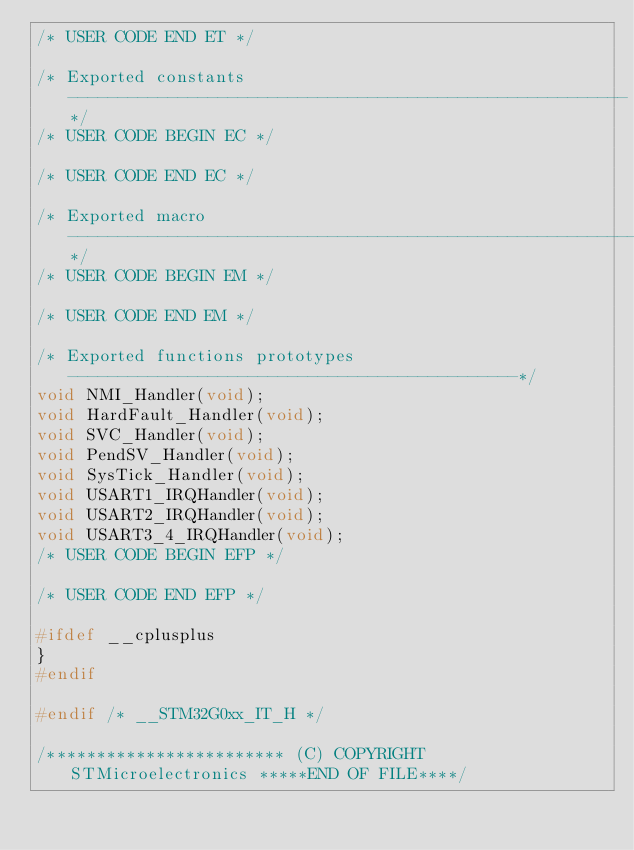Convert code to text. <code><loc_0><loc_0><loc_500><loc_500><_C_>/* USER CODE END ET */

/* Exported constants --------------------------------------------------------*/
/* USER CODE BEGIN EC */

/* USER CODE END EC */

/* Exported macro ------------------------------------------------------------*/
/* USER CODE BEGIN EM */

/* USER CODE END EM */

/* Exported functions prototypes ---------------------------------------------*/
void NMI_Handler(void);
void HardFault_Handler(void);
void SVC_Handler(void);
void PendSV_Handler(void);
void SysTick_Handler(void);
void USART1_IRQHandler(void);
void USART2_IRQHandler(void);
void USART3_4_IRQHandler(void);
/* USER CODE BEGIN EFP */

/* USER CODE END EFP */

#ifdef __cplusplus
}
#endif

#endif /* __STM32G0xx_IT_H */

/************************ (C) COPYRIGHT STMicroelectronics *****END OF FILE****/
</code> 